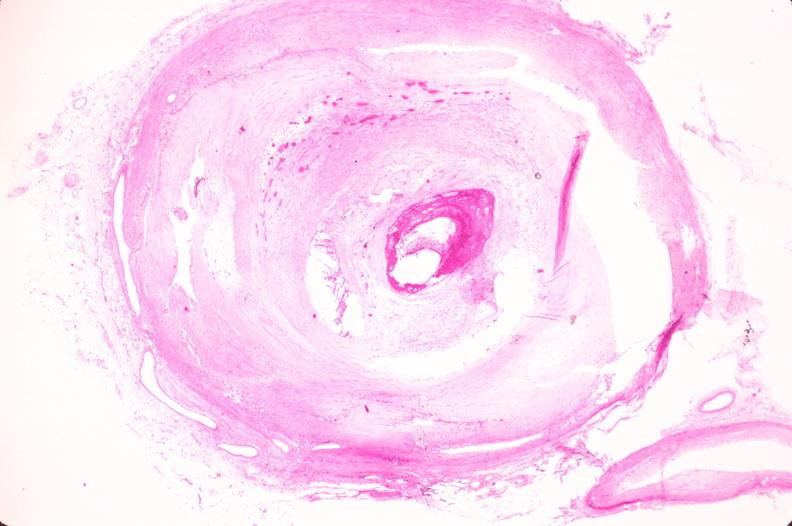what does this image show?
Answer the question using a single word or phrase. Coronary artery atherosclerosis 